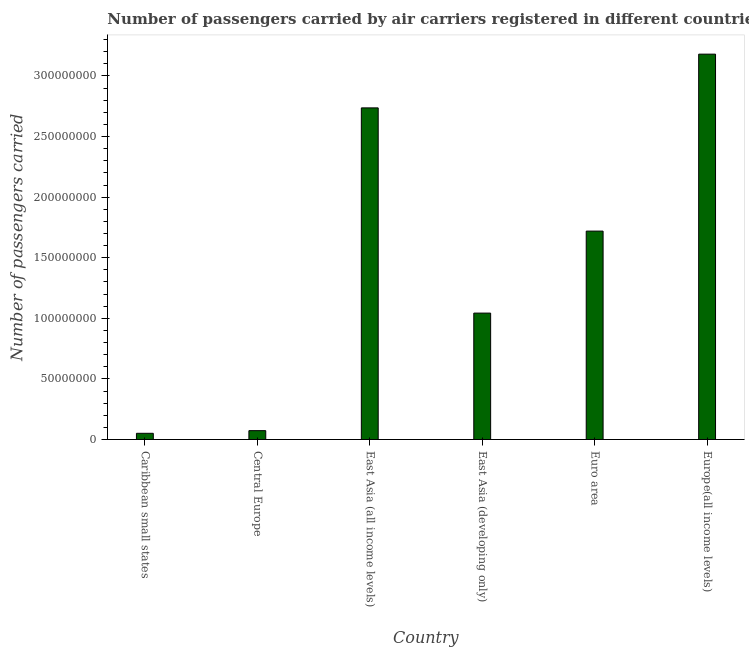Does the graph contain any zero values?
Offer a terse response. No. What is the title of the graph?
Your response must be concise. Number of passengers carried by air carriers registered in different countries. What is the label or title of the Y-axis?
Ensure brevity in your answer.  Number of passengers carried. What is the number of passengers carried in East Asia (all income levels)?
Your answer should be compact. 2.74e+08. Across all countries, what is the maximum number of passengers carried?
Offer a terse response. 3.18e+08. Across all countries, what is the minimum number of passengers carried?
Make the answer very short. 5.12e+06. In which country was the number of passengers carried maximum?
Give a very brief answer. Europe(all income levels). In which country was the number of passengers carried minimum?
Ensure brevity in your answer.  Caribbean small states. What is the sum of the number of passengers carried?
Your answer should be very brief. 8.80e+08. What is the difference between the number of passengers carried in East Asia (all income levels) and East Asia (developing only)?
Offer a very short reply. 1.69e+08. What is the average number of passengers carried per country?
Give a very brief answer. 1.47e+08. What is the median number of passengers carried?
Make the answer very short. 1.38e+08. What is the ratio of the number of passengers carried in Caribbean small states to that in Europe(all income levels)?
Give a very brief answer. 0.02. Is the number of passengers carried in East Asia (developing only) less than that in Euro area?
Ensure brevity in your answer.  Yes. What is the difference between the highest and the second highest number of passengers carried?
Make the answer very short. 4.43e+07. What is the difference between the highest and the lowest number of passengers carried?
Make the answer very short. 3.13e+08. In how many countries, is the number of passengers carried greater than the average number of passengers carried taken over all countries?
Give a very brief answer. 3. Are all the bars in the graph horizontal?
Provide a succinct answer. No. What is the difference between two consecutive major ticks on the Y-axis?
Give a very brief answer. 5.00e+07. What is the Number of passengers carried in Caribbean small states?
Your answer should be very brief. 5.12e+06. What is the Number of passengers carried in Central Europe?
Ensure brevity in your answer.  7.32e+06. What is the Number of passengers carried in East Asia (all income levels)?
Ensure brevity in your answer.  2.74e+08. What is the Number of passengers carried in East Asia (developing only)?
Give a very brief answer. 1.04e+08. What is the Number of passengers carried of Euro area?
Give a very brief answer. 1.72e+08. What is the Number of passengers carried of Europe(all income levels)?
Your answer should be very brief. 3.18e+08. What is the difference between the Number of passengers carried in Caribbean small states and Central Europe?
Make the answer very short. -2.20e+06. What is the difference between the Number of passengers carried in Caribbean small states and East Asia (all income levels)?
Offer a terse response. -2.69e+08. What is the difference between the Number of passengers carried in Caribbean small states and East Asia (developing only)?
Make the answer very short. -9.92e+07. What is the difference between the Number of passengers carried in Caribbean small states and Euro area?
Your answer should be very brief. -1.67e+08. What is the difference between the Number of passengers carried in Caribbean small states and Europe(all income levels)?
Make the answer very short. -3.13e+08. What is the difference between the Number of passengers carried in Central Europe and East Asia (all income levels)?
Your answer should be very brief. -2.66e+08. What is the difference between the Number of passengers carried in Central Europe and East Asia (developing only)?
Your response must be concise. -9.70e+07. What is the difference between the Number of passengers carried in Central Europe and Euro area?
Keep it short and to the point. -1.65e+08. What is the difference between the Number of passengers carried in Central Europe and Europe(all income levels)?
Make the answer very short. -3.11e+08. What is the difference between the Number of passengers carried in East Asia (all income levels) and East Asia (developing only)?
Your answer should be compact. 1.69e+08. What is the difference between the Number of passengers carried in East Asia (all income levels) and Euro area?
Offer a very short reply. 1.02e+08. What is the difference between the Number of passengers carried in East Asia (all income levels) and Europe(all income levels)?
Give a very brief answer. -4.43e+07. What is the difference between the Number of passengers carried in East Asia (developing only) and Euro area?
Your response must be concise. -6.77e+07. What is the difference between the Number of passengers carried in East Asia (developing only) and Europe(all income levels)?
Your response must be concise. -2.14e+08. What is the difference between the Number of passengers carried in Euro area and Europe(all income levels)?
Provide a succinct answer. -1.46e+08. What is the ratio of the Number of passengers carried in Caribbean small states to that in Central Europe?
Offer a terse response. 0.7. What is the ratio of the Number of passengers carried in Caribbean small states to that in East Asia (all income levels)?
Give a very brief answer. 0.02. What is the ratio of the Number of passengers carried in Caribbean small states to that in East Asia (developing only)?
Offer a terse response. 0.05. What is the ratio of the Number of passengers carried in Caribbean small states to that in Europe(all income levels)?
Your answer should be very brief. 0.02. What is the ratio of the Number of passengers carried in Central Europe to that in East Asia (all income levels)?
Give a very brief answer. 0.03. What is the ratio of the Number of passengers carried in Central Europe to that in East Asia (developing only)?
Offer a terse response. 0.07. What is the ratio of the Number of passengers carried in Central Europe to that in Euro area?
Keep it short and to the point. 0.04. What is the ratio of the Number of passengers carried in Central Europe to that in Europe(all income levels)?
Your answer should be very brief. 0.02. What is the ratio of the Number of passengers carried in East Asia (all income levels) to that in East Asia (developing only)?
Provide a short and direct response. 2.62. What is the ratio of the Number of passengers carried in East Asia (all income levels) to that in Euro area?
Give a very brief answer. 1.59. What is the ratio of the Number of passengers carried in East Asia (all income levels) to that in Europe(all income levels)?
Offer a very short reply. 0.86. What is the ratio of the Number of passengers carried in East Asia (developing only) to that in Euro area?
Ensure brevity in your answer.  0.61. What is the ratio of the Number of passengers carried in East Asia (developing only) to that in Europe(all income levels)?
Make the answer very short. 0.33. What is the ratio of the Number of passengers carried in Euro area to that in Europe(all income levels)?
Offer a very short reply. 0.54. 